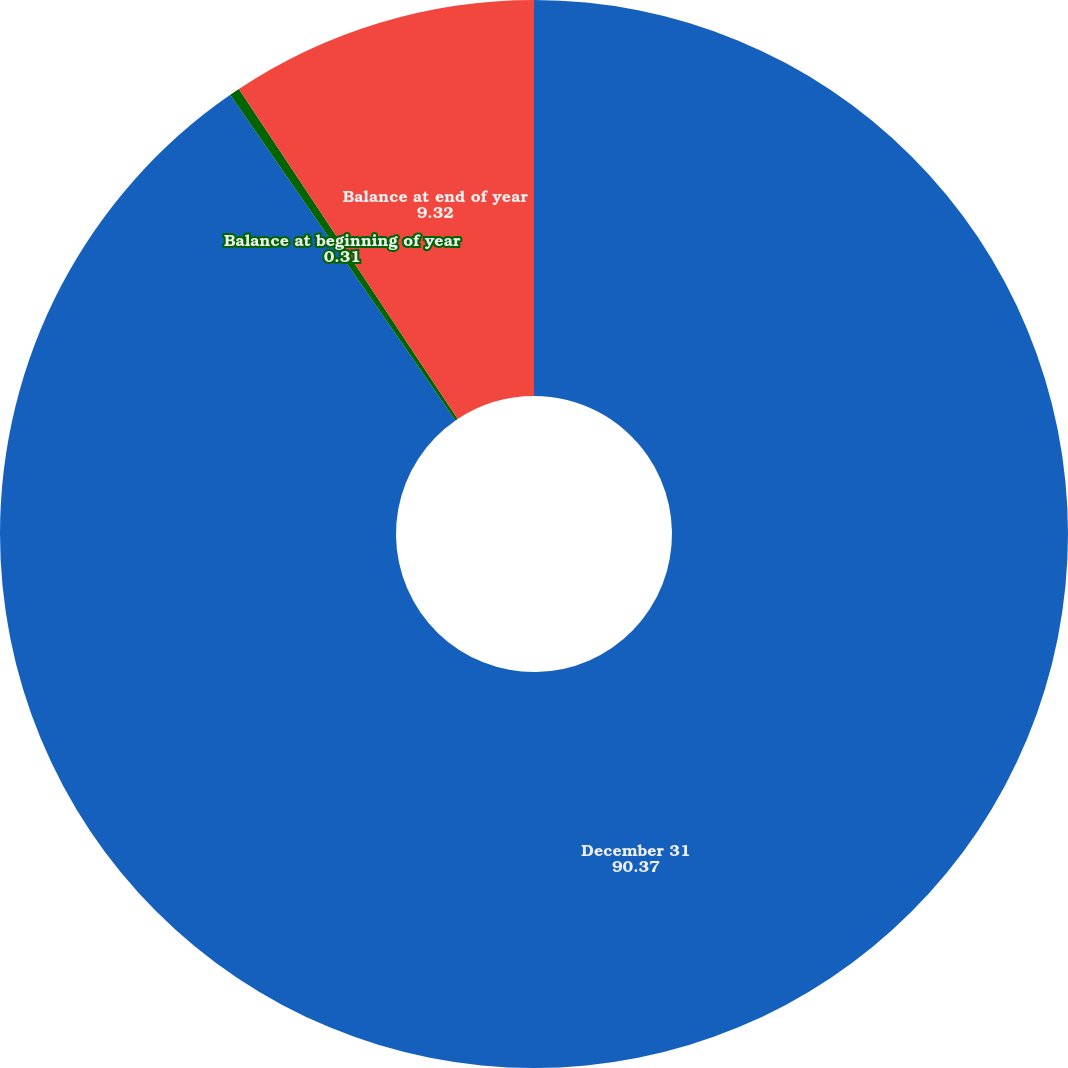Convert chart to OTSL. <chart><loc_0><loc_0><loc_500><loc_500><pie_chart><fcel>December 31<fcel>Balance at beginning of year<fcel>Balance at end of year<nl><fcel>90.37%<fcel>0.31%<fcel>9.32%<nl></chart> 